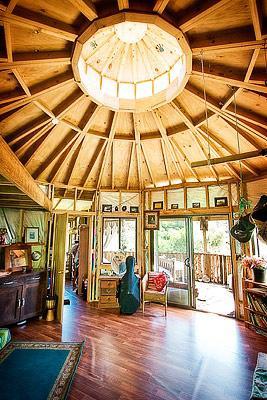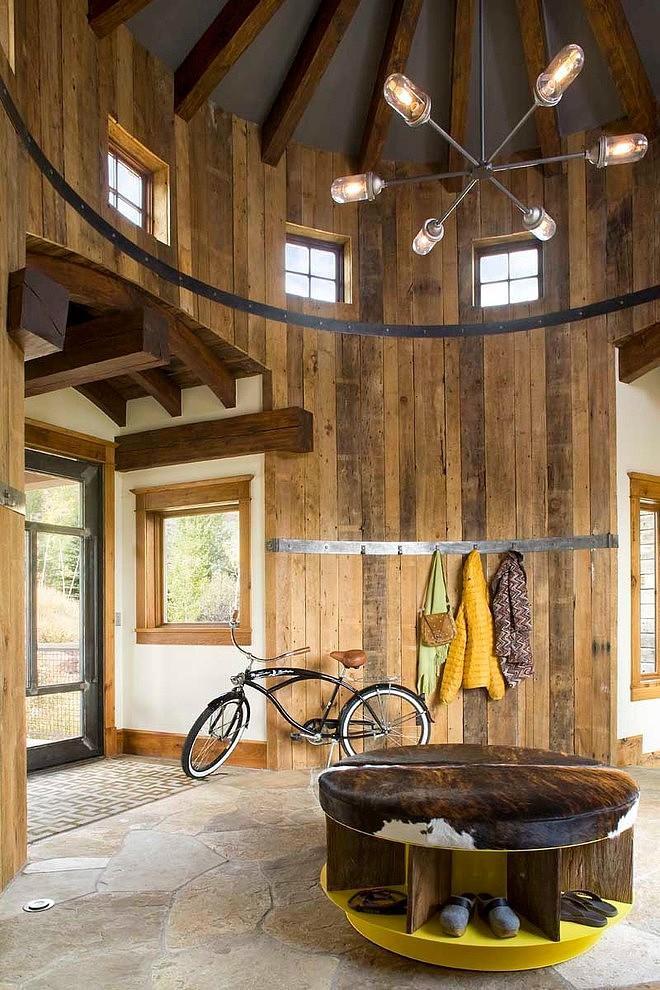The first image is the image on the left, the second image is the image on the right. Assess this claim about the two images: "There is exactly one ceiling fan in the image on the right.". Correct or not? Answer yes or no. No. 